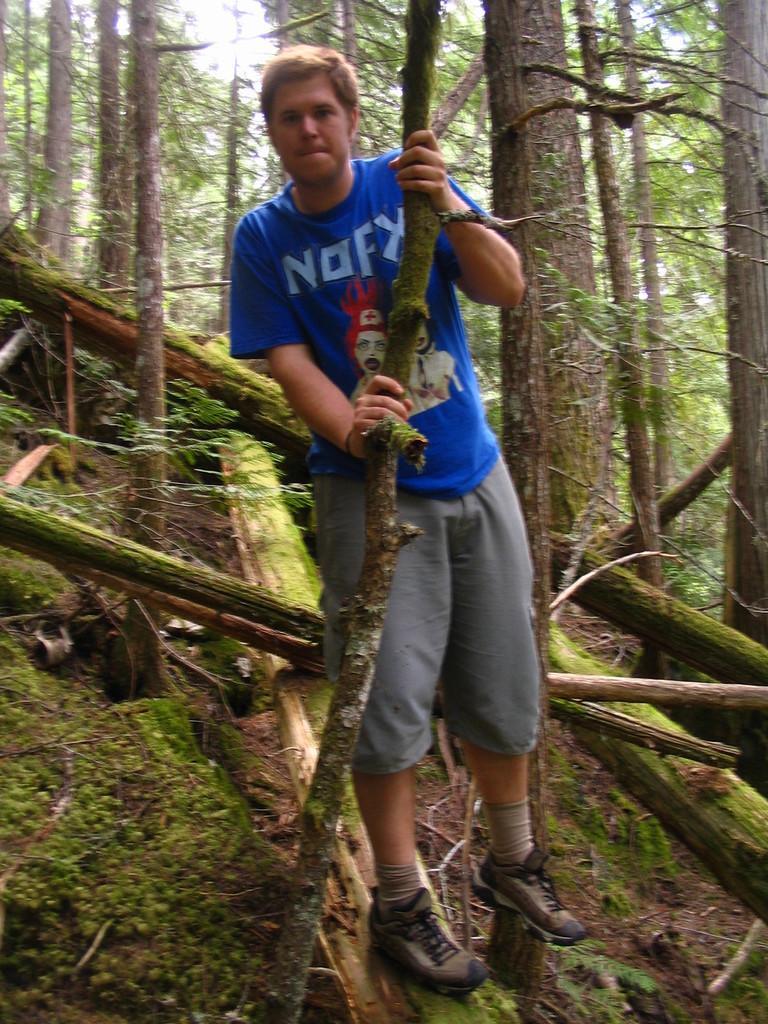Describe this image in one or two sentences. In this image there is a man standing on the ground by holding the tree. In the background there are so many tall trees. On the ground there are wooden sticks on which there is an algae. 